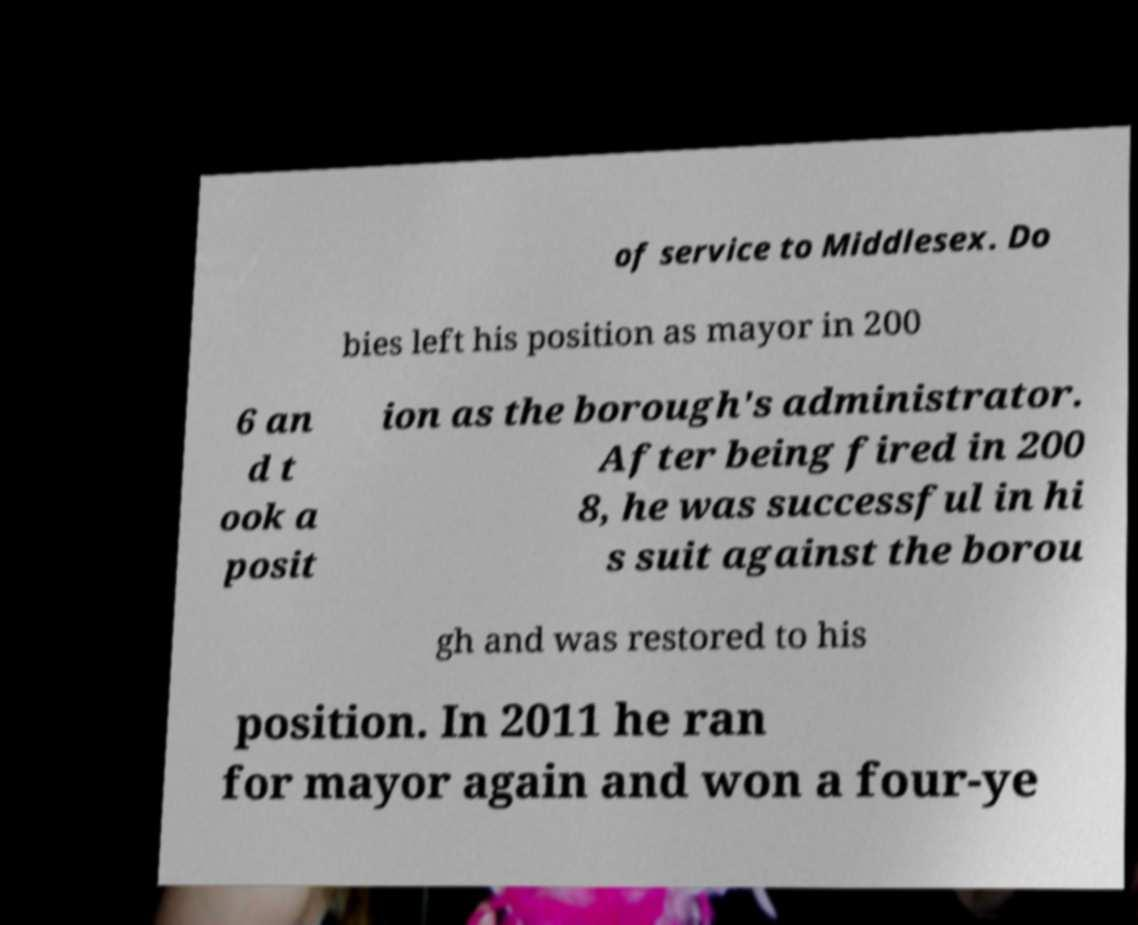Please identify and transcribe the text found in this image. of service to Middlesex. Do bies left his position as mayor in 200 6 an d t ook a posit ion as the borough's administrator. After being fired in 200 8, he was successful in hi s suit against the borou gh and was restored to his position. In 2011 he ran for mayor again and won a four-ye 